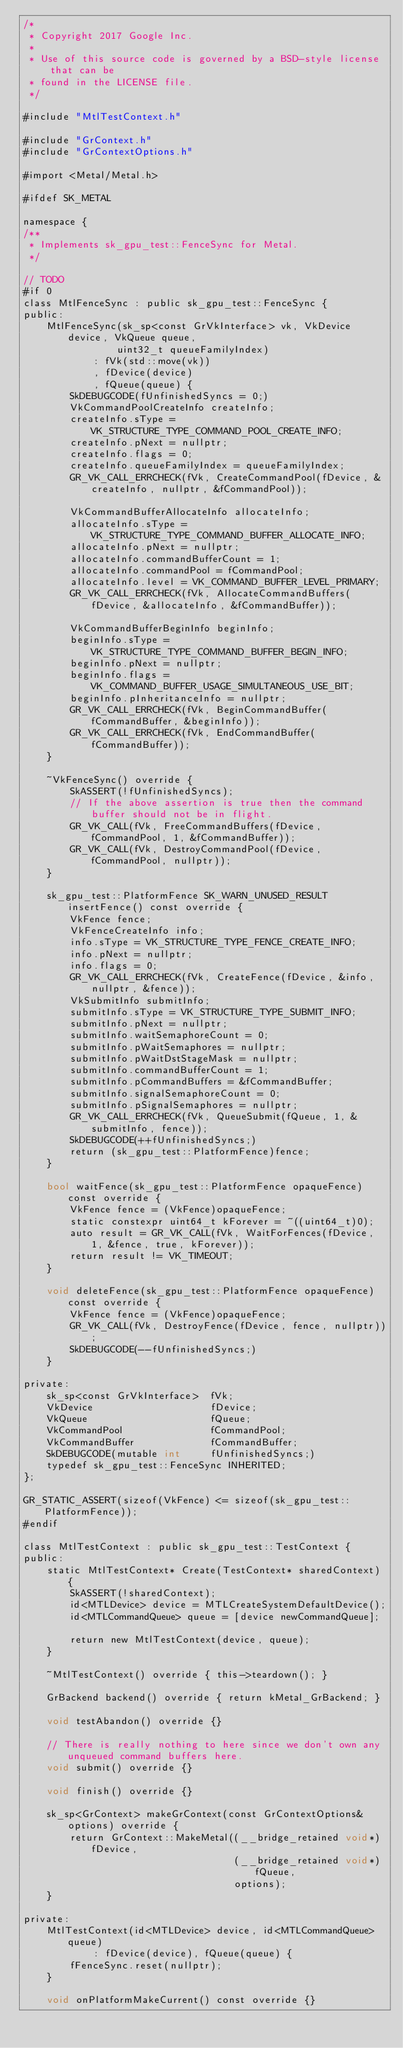Convert code to text. <code><loc_0><loc_0><loc_500><loc_500><_ObjectiveC_>/*
 * Copyright 2017 Google Inc.
 *
 * Use of this source code is governed by a BSD-style license that can be
 * found in the LICENSE file.
 */

#include "MtlTestContext.h"

#include "GrContext.h"
#include "GrContextOptions.h"

#import <Metal/Metal.h>

#ifdef SK_METAL

namespace {
/**
 * Implements sk_gpu_test::FenceSync for Metal.
 */

// TODO
#if 0
class MtlFenceSync : public sk_gpu_test::FenceSync {
public:
    MtlFenceSync(sk_sp<const GrVkInterface> vk, VkDevice device, VkQueue queue,
                uint32_t queueFamilyIndex)
            : fVk(std::move(vk))
            , fDevice(device)
            , fQueue(queue) {
        SkDEBUGCODE(fUnfinishedSyncs = 0;)
        VkCommandPoolCreateInfo createInfo;
        createInfo.sType = VK_STRUCTURE_TYPE_COMMAND_POOL_CREATE_INFO;
        createInfo.pNext = nullptr;
        createInfo.flags = 0;
        createInfo.queueFamilyIndex = queueFamilyIndex;
        GR_VK_CALL_ERRCHECK(fVk, CreateCommandPool(fDevice, &createInfo, nullptr, &fCommandPool));

        VkCommandBufferAllocateInfo allocateInfo;
        allocateInfo.sType = VK_STRUCTURE_TYPE_COMMAND_BUFFER_ALLOCATE_INFO;
        allocateInfo.pNext = nullptr;
        allocateInfo.commandBufferCount = 1;
        allocateInfo.commandPool = fCommandPool;
        allocateInfo.level = VK_COMMAND_BUFFER_LEVEL_PRIMARY;
        GR_VK_CALL_ERRCHECK(fVk, AllocateCommandBuffers(fDevice, &allocateInfo, &fCommandBuffer));

        VkCommandBufferBeginInfo beginInfo;
        beginInfo.sType = VK_STRUCTURE_TYPE_COMMAND_BUFFER_BEGIN_INFO;
        beginInfo.pNext = nullptr;
        beginInfo.flags = VK_COMMAND_BUFFER_USAGE_SIMULTANEOUS_USE_BIT;
        beginInfo.pInheritanceInfo = nullptr;
        GR_VK_CALL_ERRCHECK(fVk, BeginCommandBuffer(fCommandBuffer, &beginInfo));
        GR_VK_CALL_ERRCHECK(fVk, EndCommandBuffer(fCommandBuffer));
    }

    ~VkFenceSync() override {
        SkASSERT(!fUnfinishedSyncs);
        // If the above assertion is true then the command buffer should not be in flight.
        GR_VK_CALL(fVk, FreeCommandBuffers(fDevice, fCommandPool, 1, &fCommandBuffer));
        GR_VK_CALL(fVk, DestroyCommandPool(fDevice, fCommandPool, nullptr));
    }

    sk_gpu_test::PlatformFence SK_WARN_UNUSED_RESULT insertFence() const override {
        VkFence fence;
        VkFenceCreateInfo info;
        info.sType = VK_STRUCTURE_TYPE_FENCE_CREATE_INFO;
        info.pNext = nullptr;
        info.flags = 0;
        GR_VK_CALL_ERRCHECK(fVk, CreateFence(fDevice, &info, nullptr, &fence));
        VkSubmitInfo submitInfo;
        submitInfo.sType = VK_STRUCTURE_TYPE_SUBMIT_INFO;
        submitInfo.pNext = nullptr;
        submitInfo.waitSemaphoreCount = 0;
        submitInfo.pWaitSemaphores = nullptr;
        submitInfo.pWaitDstStageMask = nullptr;
        submitInfo.commandBufferCount = 1;
        submitInfo.pCommandBuffers = &fCommandBuffer;
        submitInfo.signalSemaphoreCount = 0;
        submitInfo.pSignalSemaphores = nullptr;
        GR_VK_CALL_ERRCHECK(fVk, QueueSubmit(fQueue, 1, &submitInfo, fence));
        SkDEBUGCODE(++fUnfinishedSyncs;)
        return (sk_gpu_test::PlatformFence)fence;
    }

    bool waitFence(sk_gpu_test::PlatformFence opaqueFence) const override {
        VkFence fence = (VkFence)opaqueFence;
        static constexpr uint64_t kForever = ~((uint64_t)0);
        auto result = GR_VK_CALL(fVk, WaitForFences(fDevice, 1, &fence, true, kForever));
        return result != VK_TIMEOUT;
    }

    void deleteFence(sk_gpu_test::PlatformFence opaqueFence) const override {
        VkFence fence = (VkFence)opaqueFence;
        GR_VK_CALL(fVk, DestroyFence(fDevice, fence, nullptr));
        SkDEBUGCODE(--fUnfinishedSyncs;)
    }

private:
    sk_sp<const GrVkInterface>  fVk;
    VkDevice                    fDevice;
    VkQueue                     fQueue;
    VkCommandPool               fCommandPool;
    VkCommandBuffer             fCommandBuffer;
    SkDEBUGCODE(mutable int     fUnfinishedSyncs;)
    typedef sk_gpu_test::FenceSync INHERITED;
};

GR_STATIC_ASSERT(sizeof(VkFence) <= sizeof(sk_gpu_test::PlatformFence));
#endif

class MtlTestContext : public sk_gpu_test::TestContext {
public:
    static MtlTestContext* Create(TestContext* sharedContext) {
        SkASSERT(!sharedContext);
        id<MTLDevice> device = MTLCreateSystemDefaultDevice();
        id<MTLCommandQueue> queue = [device newCommandQueue];

        return new MtlTestContext(device, queue);
    }

    ~MtlTestContext() override { this->teardown(); }

    GrBackend backend() override { return kMetal_GrBackend; }

    void testAbandon() override {}

    // There is really nothing to here since we don't own any unqueued command buffers here.
    void submit() override {}

    void finish() override {}

    sk_sp<GrContext> makeGrContext(const GrContextOptions& options) override {
        return GrContext::MakeMetal((__bridge_retained void*)fDevice,
                                    (__bridge_retained void*)fQueue,
                                    options);
    }

private:
    MtlTestContext(id<MTLDevice> device, id<MTLCommandQueue> queue)
            : fDevice(device), fQueue(queue) {
        fFenceSync.reset(nullptr);
    }

    void onPlatformMakeCurrent() const override {}</code> 